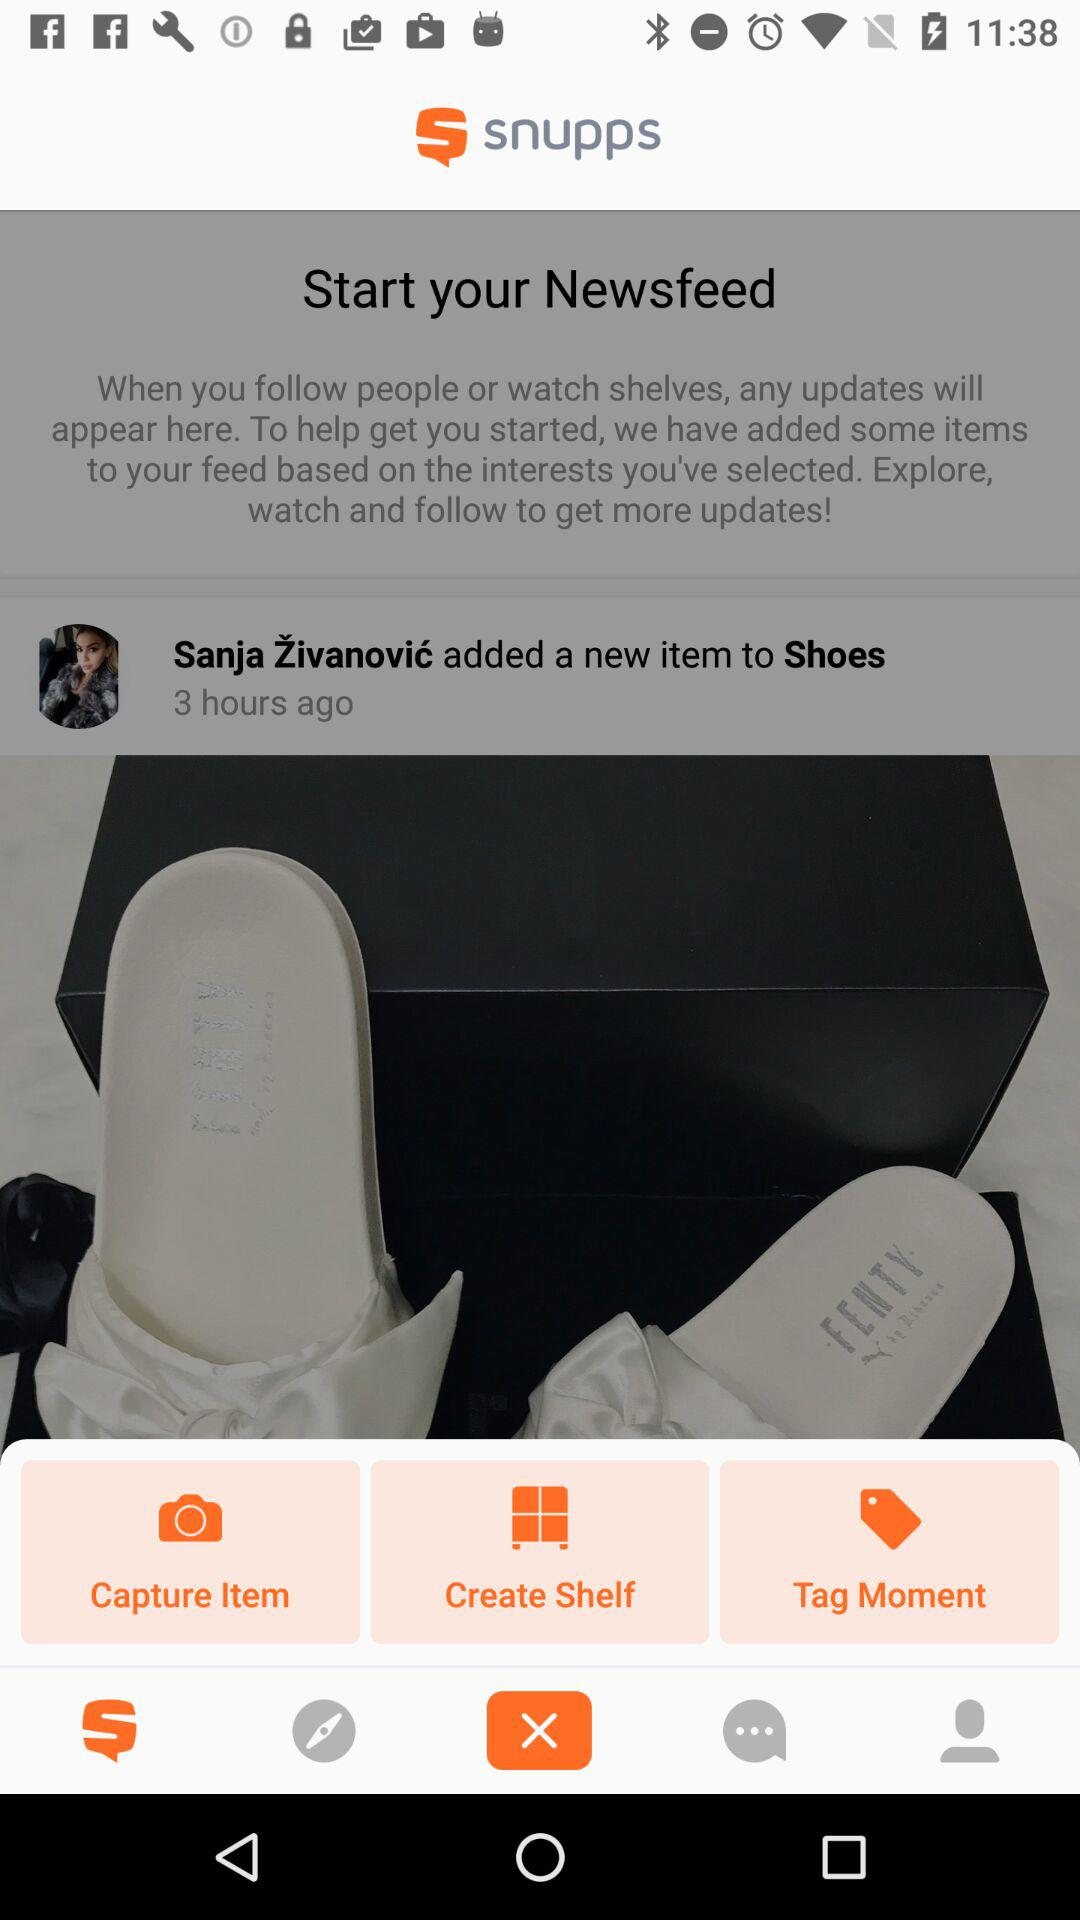What is "Start your Newsfeed"? Start your newsfeed means: "When you follow people or watch shelves, any updates will appear here. To help get you started, we have added some items to your feed based on the interests you've selected. Explore, watch and follow to get more updates!". 